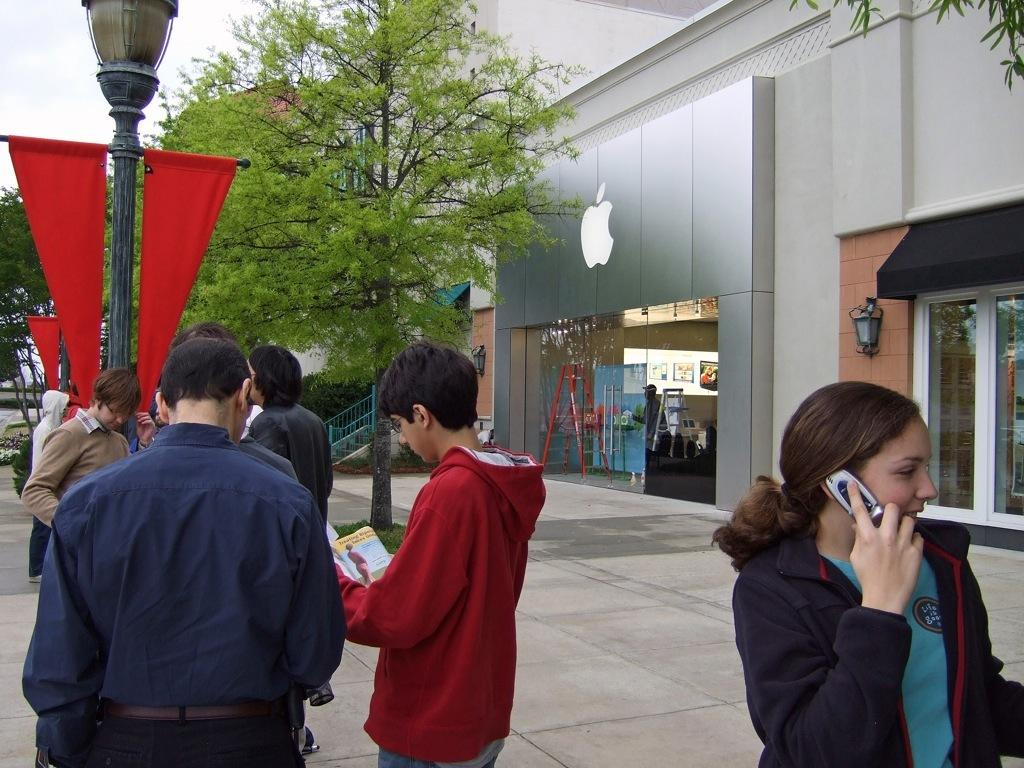What is happening on the street in the image? There are people on the street in the image. Can you describe the lady in the image? The lady is holding a phone and talking on it. What can be seen in the background of the image? There are stores, trees, lamps, and flags in the background of the image. What is the size of the plane flying over the street in the image? There is no plane visible in the image. How does the lady start her conversation on the phone in the image? The lady is already talking on the phone in the image, so we cannot see how she started the conversation. 